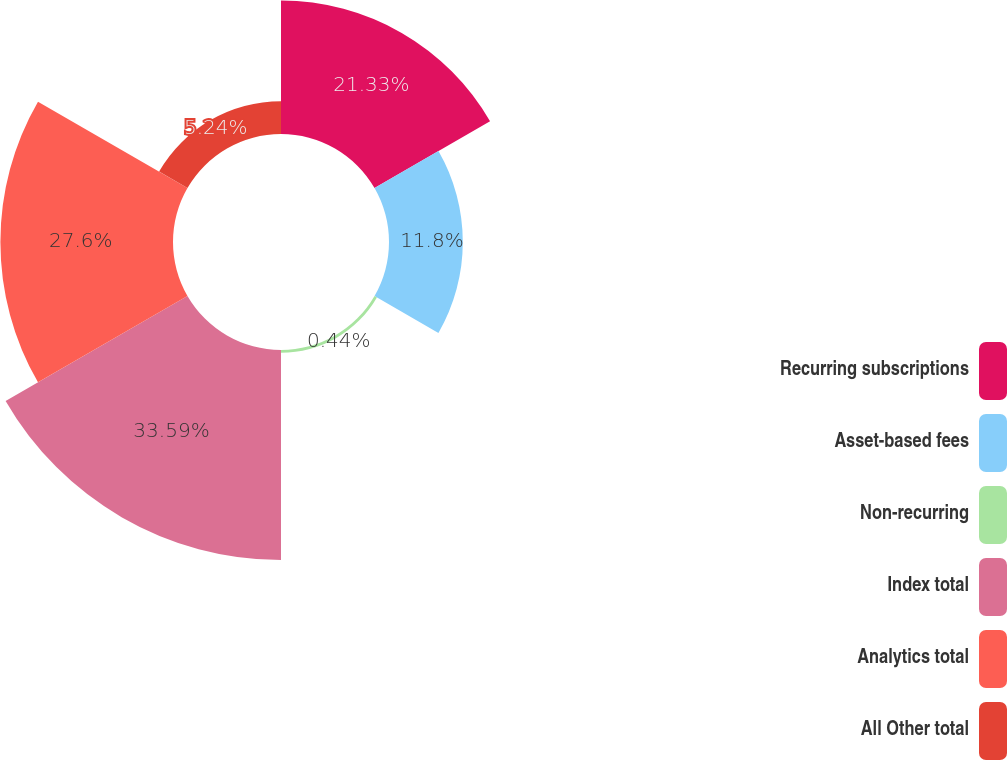Convert chart to OTSL. <chart><loc_0><loc_0><loc_500><loc_500><pie_chart><fcel>Recurring subscriptions<fcel>Asset-based fees<fcel>Non-recurring<fcel>Index total<fcel>Analytics total<fcel>All Other total<nl><fcel>21.33%<fcel>11.8%<fcel>0.44%<fcel>33.58%<fcel>27.6%<fcel>5.24%<nl></chart> 